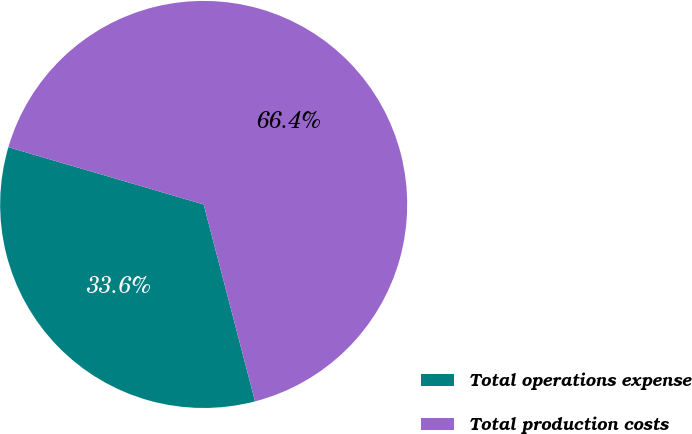Convert chart to OTSL. <chart><loc_0><loc_0><loc_500><loc_500><pie_chart><fcel>Total operations expense<fcel>Total production costs<nl><fcel>33.6%<fcel>66.4%<nl></chart> 